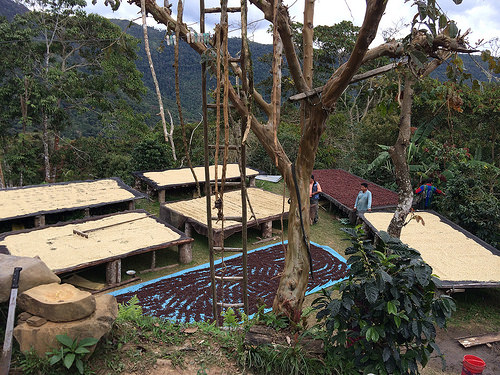<image>
Can you confirm if the machete is in the rock? No. The machete is not contained within the rock. These objects have a different spatial relationship. 